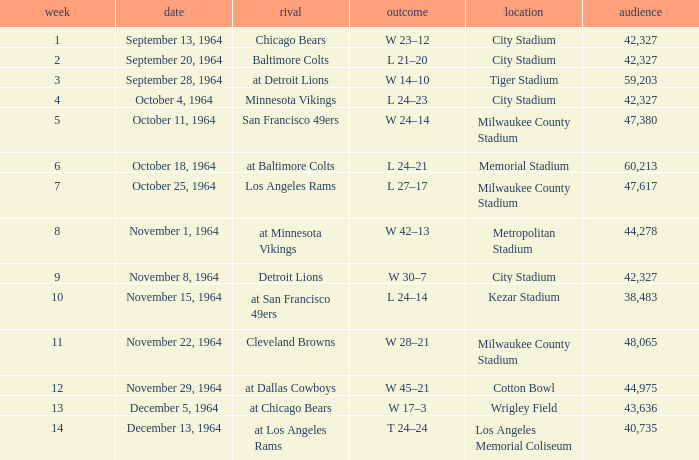What is the average attendance at a week 4 game? 42327.0. Write the full table. {'header': ['week', 'date', 'rival', 'outcome', 'location', 'audience'], 'rows': [['1', 'September 13, 1964', 'Chicago Bears', 'W 23–12', 'City Stadium', '42,327'], ['2', 'September 20, 1964', 'Baltimore Colts', 'L 21–20', 'City Stadium', '42,327'], ['3', 'September 28, 1964', 'at Detroit Lions', 'W 14–10', 'Tiger Stadium', '59,203'], ['4', 'October 4, 1964', 'Minnesota Vikings', 'L 24–23', 'City Stadium', '42,327'], ['5', 'October 11, 1964', 'San Francisco 49ers', 'W 24–14', 'Milwaukee County Stadium', '47,380'], ['6', 'October 18, 1964', 'at Baltimore Colts', 'L 24–21', 'Memorial Stadium', '60,213'], ['7', 'October 25, 1964', 'Los Angeles Rams', 'L 27–17', 'Milwaukee County Stadium', '47,617'], ['8', 'November 1, 1964', 'at Minnesota Vikings', 'W 42–13', 'Metropolitan Stadium', '44,278'], ['9', 'November 8, 1964', 'Detroit Lions', 'W 30–7', 'City Stadium', '42,327'], ['10', 'November 15, 1964', 'at San Francisco 49ers', 'L 24–14', 'Kezar Stadium', '38,483'], ['11', 'November 22, 1964', 'Cleveland Browns', 'W 28–21', 'Milwaukee County Stadium', '48,065'], ['12', 'November 29, 1964', 'at Dallas Cowboys', 'W 45–21', 'Cotton Bowl', '44,975'], ['13', 'December 5, 1964', 'at Chicago Bears', 'W 17–3', 'Wrigley Field', '43,636'], ['14', 'December 13, 1964', 'at Los Angeles Rams', 'T 24–24', 'Los Angeles Memorial Coliseum', '40,735']]} 